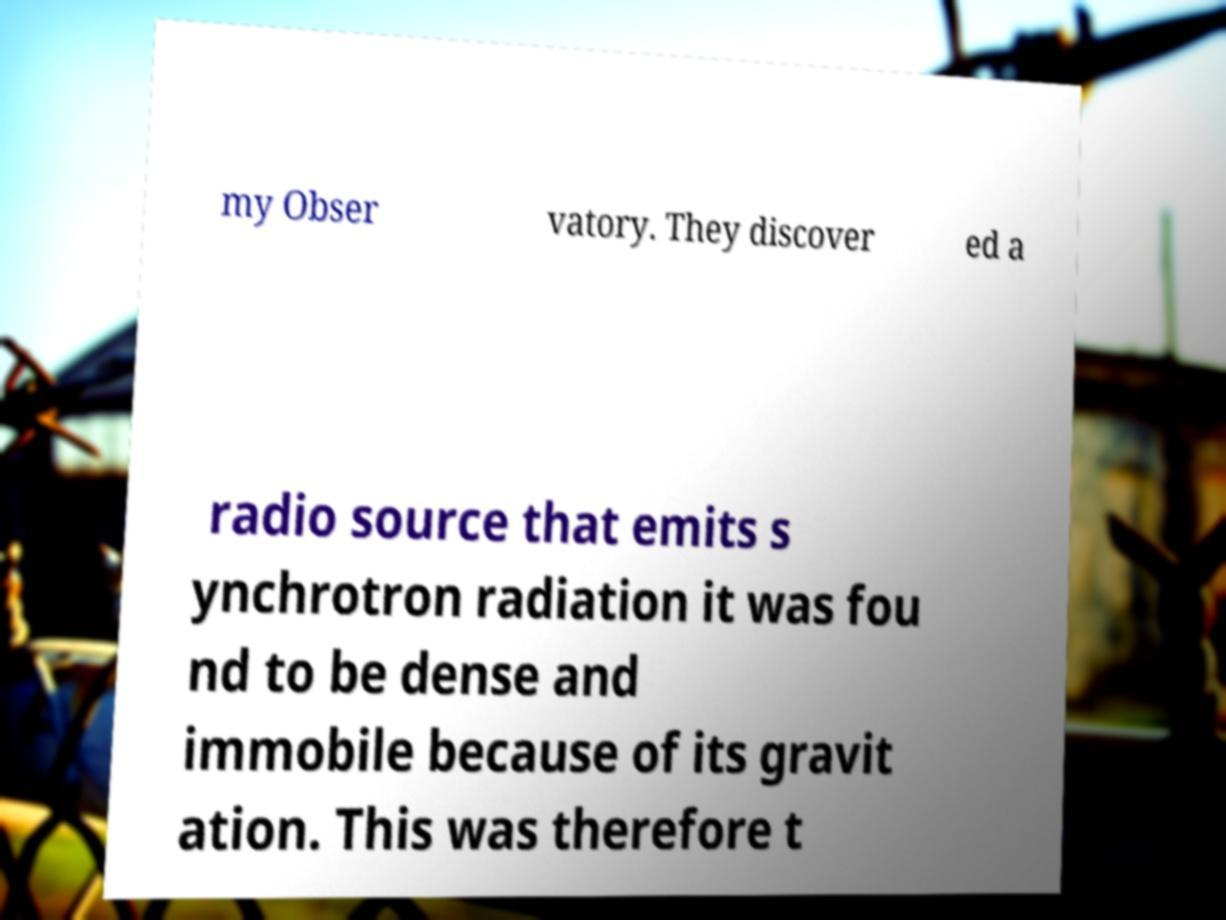Please identify and transcribe the text found in this image. my Obser vatory. They discover ed a radio source that emits s ynchrotron radiation it was fou nd to be dense and immobile because of its gravit ation. This was therefore t 